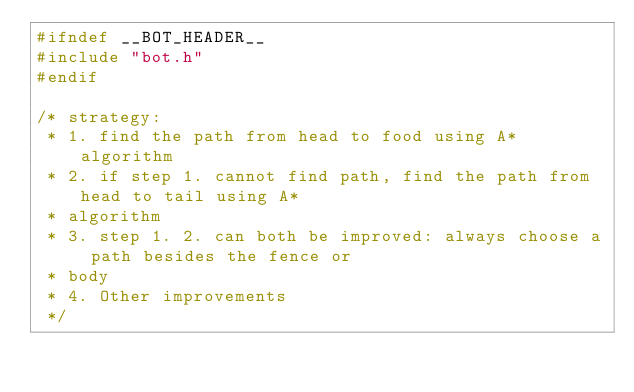Convert code to text. <code><loc_0><loc_0><loc_500><loc_500><_C++_>#ifndef __BOT_HEADER__
#include "bot.h"
#endif

/* strategy:
 * 1. find the path from head to food using A* algorithm
 * 2. if step 1. cannot find path, find the path from head to tail using A*
 * algorithm
 * 3. step 1. 2. can both be improved: always choose a path besides the fence or
 * body
 * 4. Other improvements
 */
</code> 